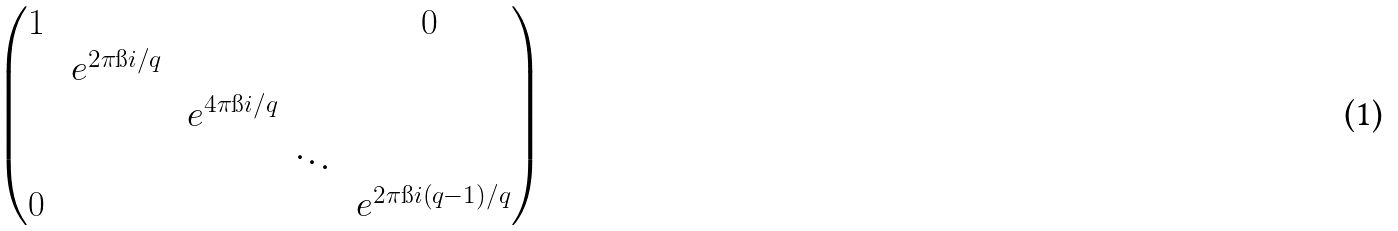<formula> <loc_0><loc_0><loc_500><loc_500>\begin{pmatrix} 1 & & & & 0 \\ & \ e ^ { 2 \pi \i i / q } & & & \\ & & \ e ^ { 4 \pi \i i / q } & & \\ & & & \ddots & \\ 0 & & & & \ e ^ { 2 \pi \i i ( q - 1 ) / q } \end{pmatrix}</formula> 